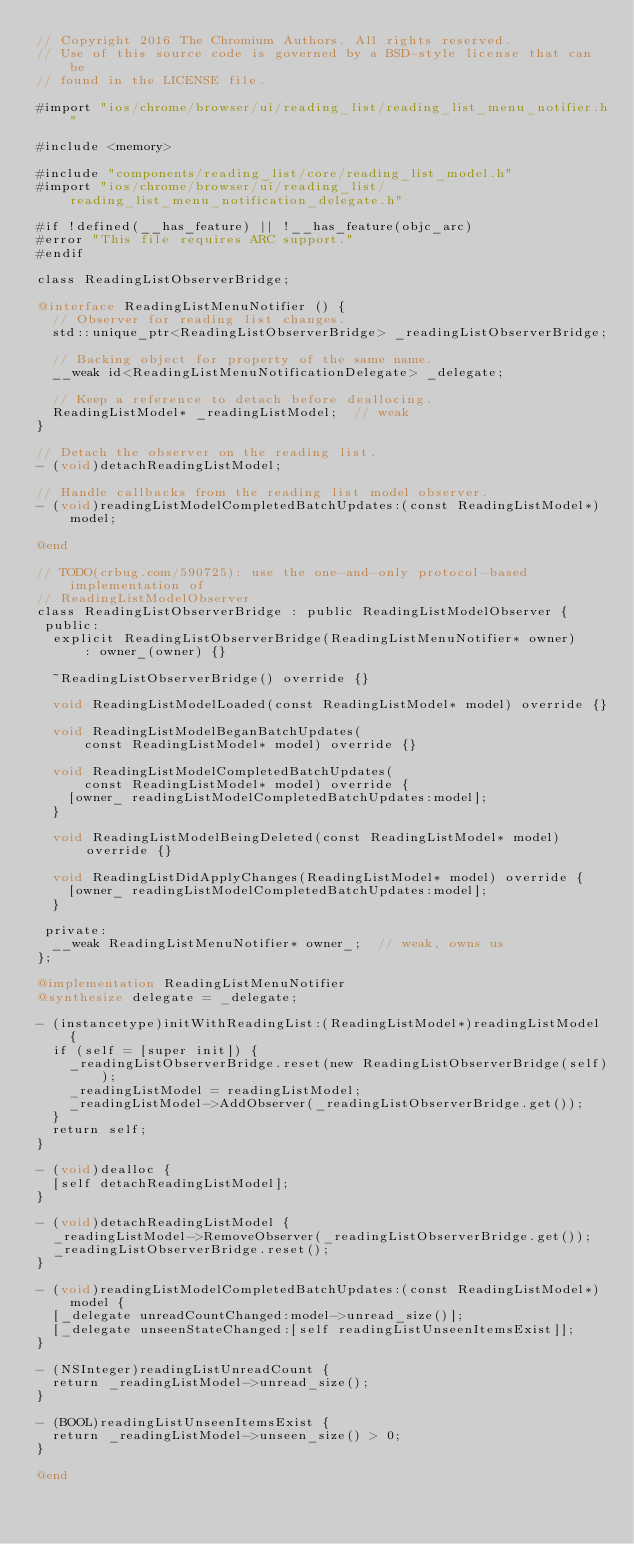<code> <loc_0><loc_0><loc_500><loc_500><_ObjectiveC_>// Copyright 2016 The Chromium Authors. All rights reserved.
// Use of this source code is governed by a BSD-style license that can be
// found in the LICENSE file.

#import "ios/chrome/browser/ui/reading_list/reading_list_menu_notifier.h"

#include <memory>

#include "components/reading_list/core/reading_list_model.h"
#import "ios/chrome/browser/ui/reading_list/reading_list_menu_notification_delegate.h"

#if !defined(__has_feature) || !__has_feature(objc_arc)
#error "This file requires ARC support."
#endif

class ReadingListObserverBridge;

@interface ReadingListMenuNotifier () {
  // Observer for reading list changes.
  std::unique_ptr<ReadingListObserverBridge> _readingListObserverBridge;

  // Backing object for property of the same name.
  __weak id<ReadingListMenuNotificationDelegate> _delegate;

  // Keep a reference to detach before deallocing.
  ReadingListModel* _readingListModel;  // weak
}

// Detach the observer on the reading list.
- (void)detachReadingListModel;

// Handle callbacks from the reading list model observer.
- (void)readingListModelCompletedBatchUpdates:(const ReadingListModel*)model;

@end

// TODO(crbug.com/590725): use the one-and-only protocol-based implementation of
// ReadingListModelObserver
class ReadingListObserverBridge : public ReadingListModelObserver {
 public:
  explicit ReadingListObserverBridge(ReadingListMenuNotifier* owner)
      : owner_(owner) {}

  ~ReadingListObserverBridge() override {}

  void ReadingListModelLoaded(const ReadingListModel* model) override {}

  void ReadingListModelBeganBatchUpdates(
      const ReadingListModel* model) override {}

  void ReadingListModelCompletedBatchUpdates(
      const ReadingListModel* model) override {
    [owner_ readingListModelCompletedBatchUpdates:model];
  }

  void ReadingListModelBeingDeleted(const ReadingListModel* model) override {}

  void ReadingListDidApplyChanges(ReadingListModel* model) override {
    [owner_ readingListModelCompletedBatchUpdates:model];
  }

 private:
  __weak ReadingListMenuNotifier* owner_;  // weak, owns us
};

@implementation ReadingListMenuNotifier
@synthesize delegate = _delegate;

- (instancetype)initWithReadingList:(ReadingListModel*)readingListModel {
  if (self = [super init]) {
    _readingListObserverBridge.reset(new ReadingListObserverBridge(self));
    _readingListModel = readingListModel;
    _readingListModel->AddObserver(_readingListObserverBridge.get());
  }
  return self;
}

- (void)dealloc {
  [self detachReadingListModel];
}

- (void)detachReadingListModel {
  _readingListModel->RemoveObserver(_readingListObserverBridge.get());
  _readingListObserverBridge.reset();
}

- (void)readingListModelCompletedBatchUpdates:(const ReadingListModel*)model {
  [_delegate unreadCountChanged:model->unread_size()];
  [_delegate unseenStateChanged:[self readingListUnseenItemsExist]];
}

- (NSInteger)readingListUnreadCount {
  return _readingListModel->unread_size();
}

- (BOOL)readingListUnseenItemsExist {
  return _readingListModel->unseen_size() > 0;
}

@end
</code> 